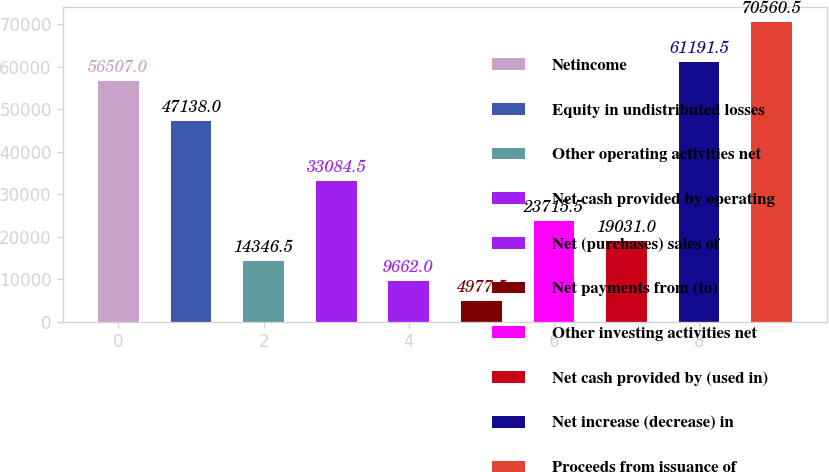Convert chart. <chart><loc_0><loc_0><loc_500><loc_500><bar_chart><fcel>Netincome<fcel>Equity in undistributed losses<fcel>Other operating activities net<fcel>Net cash provided by operating<fcel>Net (purchases) sales of<fcel>Net payments from (to)<fcel>Other investing activities net<fcel>Net cash provided by (used in)<fcel>Net increase (decrease) in<fcel>Proceeds from issuance of<nl><fcel>56507<fcel>47138<fcel>14346.5<fcel>33084.5<fcel>9662<fcel>4977.5<fcel>23715.5<fcel>19031<fcel>61191.5<fcel>70560.5<nl></chart> 